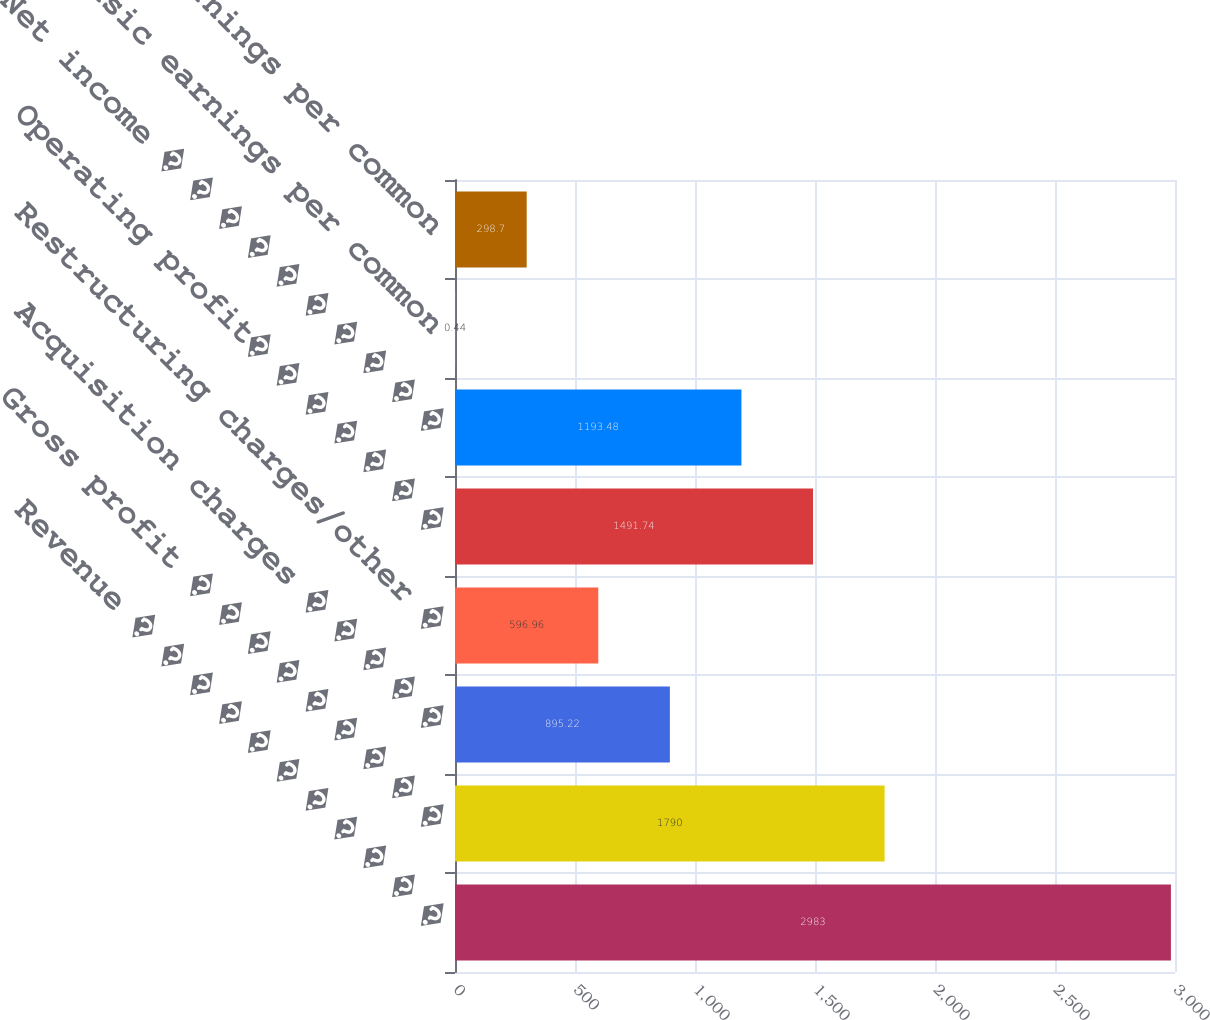Convert chart. <chart><loc_0><loc_0><loc_500><loc_500><bar_chart><fcel>Revenue � � � � � � � � � � �<fcel>Gross profit � � � � � � � � �<fcel>Acquisition charges � � � � �<fcel>Restructuring charges/other �<fcel>Operating profit� � � � � � �<fcel>Net income � � � � � � � � � �<fcel>Basic earnings per common<fcel>Diluted earnings per common<nl><fcel>2983<fcel>1790<fcel>895.22<fcel>596.96<fcel>1491.74<fcel>1193.48<fcel>0.44<fcel>298.7<nl></chart> 